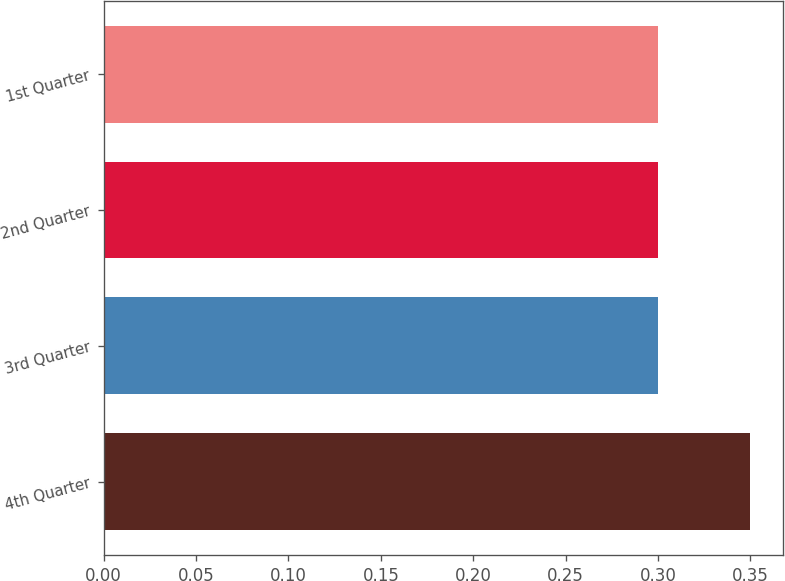Convert chart to OTSL. <chart><loc_0><loc_0><loc_500><loc_500><bar_chart><fcel>4th Quarter<fcel>3rd Quarter<fcel>2nd Quarter<fcel>1st Quarter<nl><fcel>0.35<fcel>0.3<fcel>0.3<fcel>0.3<nl></chart> 